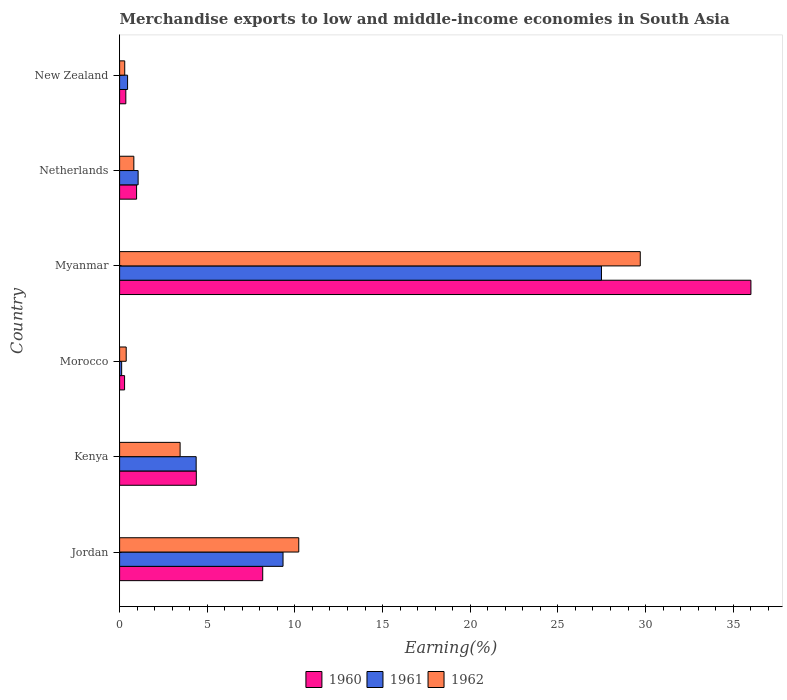How many different coloured bars are there?
Offer a very short reply. 3. Are the number of bars per tick equal to the number of legend labels?
Your answer should be compact. Yes. Are the number of bars on each tick of the Y-axis equal?
Give a very brief answer. Yes. What is the label of the 2nd group of bars from the top?
Offer a very short reply. Netherlands. In how many cases, is the number of bars for a given country not equal to the number of legend labels?
Ensure brevity in your answer.  0. What is the percentage of amount earned from merchandise exports in 1961 in Morocco?
Keep it short and to the point. 0.12. Across all countries, what is the maximum percentage of amount earned from merchandise exports in 1961?
Your answer should be very brief. 27.48. Across all countries, what is the minimum percentage of amount earned from merchandise exports in 1961?
Offer a very short reply. 0.12. In which country was the percentage of amount earned from merchandise exports in 1961 maximum?
Provide a short and direct response. Myanmar. In which country was the percentage of amount earned from merchandise exports in 1961 minimum?
Keep it short and to the point. Morocco. What is the total percentage of amount earned from merchandise exports in 1961 in the graph?
Ensure brevity in your answer.  42.8. What is the difference between the percentage of amount earned from merchandise exports in 1960 in Netherlands and that in New Zealand?
Make the answer very short. 0.61. What is the difference between the percentage of amount earned from merchandise exports in 1962 in Jordan and the percentage of amount earned from merchandise exports in 1961 in Kenya?
Your response must be concise. 5.85. What is the average percentage of amount earned from merchandise exports in 1961 per country?
Your answer should be very brief. 7.13. What is the difference between the percentage of amount earned from merchandise exports in 1962 and percentage of amount earned from merchandise exports in 1960 in Kenya?
Your response must be concise. -0.92. In how many countries, is the percentage of amount earned from merchandise exports in 1961 greater than 21 %?
Make the answer very short. 1. What is the ratio of the percentage of amount earned from merchandise exports in 1962 in Kenya to that in Myanmar?
Your response must be concise. 0.12. Is the difference between the percentage of amount earned from merchandise exports in 1962 in Morocco and Myanmar greater than the difference between the percentage of amount earned from merchandise exports in 1960 in Morocco and Myanmar?
Provide a short and direct response. Yes. What is the difference between the highest and the second highest percentage of amount earned from merchandise exports in 1962?
Your answer should be very brief. 19.48. What is the difference between the highest and the lowest percentage of amount earned from merchandise exports in 1962?
Offer a terse response. 29.4. What does the 2nd bar from the top in Kenya represents?
Your answer should be compact. 1961. Are all the bars in the graph horizontal?
Your answer should be very brief. Yes. How many countries are there in the graph?
Provide a short and direct response. 6. What is the difference between two consecutive major ticks on the X-axis?
Offer a very short reply. 5. Are the values on the major ticks of X-axis written in scientific E-notation?
Provide a succinct answer. No. Where does the legend appear in the graph?
Make the answer very short. Bottom center. What is the title of the graph?
Give a very brief answer. Merchandise exports to low and middle-income economies in South Asia. Does "1972" appear as one of the legend labels in the graph?
Offer a very short reply. No. What is the label or title of the X-axis?
Keep it short and to the point. Earning(%). What is the Earning(%) of 1960 in Jordan?
Provide a succinct answer. 8.16. What is the Earning(%) of 1961 in Jordan?
Your answer should be very brief. 9.32. What is the Earning(%) in 1962 in Jordan?
Your answer should be compact. 10.22. What is the Earning(%) of 1960 in Kenya?
Offer a very short reply. 4.38. What is the Earning(%) of 1961 in Kenya?
Your response must be concise. 4.37. What is the Earning(%) of 1962 in Kenya?
Provide a short and direct response. 3.45. What is the Earning(%) in 1960 in Morocco?
Provide a short and direct response. 0.28. What is the Earning(%) in 1961 in Morocco?
Provide a succinct answer. 0.12. What is the Earning(%) of 1962 in Morocco?
Provide a short and direct response. 0.38. What is the Earning(%) of 1960 in Myanmar?
Your answer should be compact. 36.01. What is the Earning(%) in 1961 in Myanmar?
Keep it short and to the point. 27.48. What is the Earning(%) in 1962 in Myanmar?
Offer a terse response. 29.7. What is the Earning(%) in 1960 in Netherlands?
Ensure brevity in your answer.  0.97. What is the Earning(%) of 1961 in Netherlands?
Offer a terse response. 1.06. What is the Earning(%) in 1962 in Netherlands?
Provide a succinct answer. 0.81. What is the Earning(%) in 1960 in New Zealand?
Keep it short and to the point. 0.36. What is the Earning(%) of 1961 in New Zealand?
Offer a very short reply. 0.45. What is the Earning(%) of 1962 in New Zealand?
Your response must be concise. 0.29. Across all countries, what is the maximum Earning(%) in 1960?
Keep it short and to the point. 36.01. Across all countries, what is the maximum Earning(%) of 1961?
Keep it short and to the point. 27.48. Across all countries, what is the maximum Earning(%) in 1962?
Provide a short and direct response. 29.7. Across all countries, what is the minimum Earning(%) in 1960?
Offer a very short reply. 0.28. Across all countries, what is the minimum Earning(%) of 1961?
Your response must be concise. 0.12. Across all countries, what is the minimum Earning(%) of 1962?
Provide a succinct answer. 0.29. What is the total Earning(%) of 1960 in the graph?
Your answer should be very brief. 50.16. What is the total Earning(%) in 1961 in the graph?
Ensure brevity in your answer.  42.8. What is the total Earning(%) of 1962 in the graph?
Offer a terse response. 44.85. What is the difference between the Earning(%) in 1960 in Jordan and that in Kenya?
Your response must be concise. 3.79. What is the difference between the Earning(%) in 1961 in Jordan and that in Kenya?
Your answer should be very brief. 4.96. What is the difference between the Earning(%) in 1962 in Jordan and that in Kenya?
Your answer should be compact. 6.77. What is the difference between the Earning(%) of 1960 in Jordan and that in Morocco?
Ensure brevity in your answer.  7.88. What is the difference between the Earning(%) of 1961 in Jordan and that in Morocco?
Provide a succinct answer. 9.21. What is the difference between the Earning(%) in 1962 in Jordan and that in Morocco?
Your response must be concise. 9.84. What is the difference between the Earning(%) of 1960 in Jordan and that in Myanmar?
Make the answer very short. -27.85. What is the difference between the Earning(%) in 1961 in Jordan and that in Myanmar?
Your answer should be compact. -18.16. What is the difference between the Earning(%) of 1962 in Jordan and that in Myanmar?
Ensure brevity in your answer.  -19.48. What is the difference between the Earning(%) in 1960 in Jordan and that in Netherlands?
Offer a terse response. 7.19. What is the difference between the Earning(%) in 1961 in Jordan and that in Netherlands?
Offer a very short reply. 8.27. What is the difference between the Earning(%) in 1962 in Jordan and that in Netherlands?
Ensure brevity in your answer.  9.41. What is the difference between the Earning(%) of 1960 in Jordan and that in New Zealand?
Offer a terse response. 7.81. What is the difference between the Earning(%) in 1961 in Jordan and that in New Zealand?
Give a very brief answer. 8.87. What is the difference between the Earning(%) of 1962 in Jordan and that in New Zealand?
Ensure brevity in your answer.  9.93. What is the difference between the Earning(%) in 1960 in Kenya and that in Morocco?
Keep it short and to the point. 4.09. What is the difference between the Earning(%) in 1961 in Kenya and that in Morocco?
Provide a short and direct response. 4.25. What is the difference between the Earning(%) in 1962 in Kenya and that in Morocco?
Ensure brevity in your answer.  3.07. What is the difference between the Earning(%) in 1960 in Kenya and that in Myanmar?
Offer a terse response. -31.63. What is the difference between the Earning(%) of 1961 in Kenya and that in Myanmar?
Keep it short and to the point. -23.12. What is the difference between the Earning(%) in 1962 in Kenya and that in Myanmar?
Ensure brevity in your answer.  -26.25. What is the difference between the Earning(%) of 1960 in Kenya and that in Netherlands?
Provide a short and direct response. 3.41. What is the difference between the Earning(%) of 1961 in Kenya and that in Netherlands?
Provide a succinct answer. 3.31. What is the difference between the Earning(%) of 1962 in Kenya and that in Netherlands?
Provide a short and direct response. 2.64. What is the difference between the Earning(%) of 1960 in Kenya and that in New Zealand?
Provide a short and direct response. 4.02. What is the difference between the Earning(%) of 1961 in Kenya and that in New Zealand?
Provide a succinct answer. 3.91. What is the difference between the Earning(%) of 1962 in Kenya and that in New Zealand?
Ensure brevity in your answer.  3.16. What is the difference between the Earning(%) of 1960 in Morocco and that in Myanmar?
Your response must be concise. -35.73. What is the difference between the Earning(%) of 1961 in Morocco and that in Myanmar?
Make the answer very short. -27.37. What is the difference between the Earning(%) in 1962 in Morocco and that in Myanmar?
Ensure brevity in your answer.  -29.32. What is the difference between the Earning(%) in 1960 in Morocco and that in Netherlands?
Give a very brief answer. -0.68. What is the difference between the Earning(%) of 1961 in Morocco and that in Netherlands?
Offer a very short reply. -0.94. What is the difference between the Earning(%) of 1962 in Morocco and that in Netherlands?
Offer a terse response. -0.44. What is the difference between the Earning(%) in 1960 in Morocco and that in New Zealand?
Make the answer very short. -0.07. What is the difference between the Earning(%) of 1961 in Morocco and that in New Zealand?
Provide a succinct answer. -0.34. What is the difference between the Earning(%) in 1962 in Morocco and that in New Zealand?
Provide a short and direct response. 0.08. What is the difference between the Earning(%) of 1960 in Myanmar and that in Netherlands?
Provide a short and direct response. 35.04. What is the difference between the Earning(%) in 1961 in Myanmar and that in Netherlands?
Offer a very short reply. 26.43. What is the difference between the Earning(%) of 1962 in Myanmar and that in Netherlands?
Your answer should be compact. 28.89. What is the difference between the Earning(%) of 1960 in Myanmar and that in New Zealand?
Provide a short and direct response. 35.65. What is the difference between the Earning(%) in 1961 in Myanmar and that in New Zealand?
Your response must be concise. 27.03. What is the difference between the Earning(%) in 1962 in Myanmar and that in New Zealand?
Your answer should be compact. 29.4. What is the difference between the Earning(%) in 1960 in Netherlands and that in New Zealand?
Make the answer very short. 0.61. What is the difference between the Earning(%) of 1961 in Netherlands and that in New Zealand?
Offer a terse response. 0.6. What is the difference between the Earning(%) in 1962 in Netherlands and that in New Zealand?
Make the answer very short. 0.52. What is the difference between the Earning(%) in 1960 in Jordan and the Earning(%) in 1961 in Kenya?
Give a very brief answer. 3.8. What is the difference between the Earning(%) in 1960 in Jordan and the Earning(%) in 1962 in Kenya?
Offer a terse response. 4.71. What is the difference between the Earning(%) of 1961 in Jordan and the Earning(%) of 1962 in Kenya?
Your answer should be very brief. 5.87. What is the difference between the Earning(%) in 1960 in Jordan and the Earning(%) in 1961 in Morocco?
Offer a terse response. 8.05. What is the difference between the Earning(%) in 1960 in Jordan and the Earning(%) in 1962 in Morocco?
Your answer should be compact. 7.79. What is the difference between the Earning(%) of 1961 in Jordan and the Earning(%) of 1962 in Morocco?
Offer a very short reply. 8.95. What is the difference between the Earning(%) in 1960 in Jordan and the Earning(%) in 1961 in Myanmar?
Provide a succinct answer. -19.32. What is the difference between the Earning(%) of 1960 in Jordan and the Earning(%) of 1962 in Myanmar?
Provide a succinct answer. -21.53. What is the difference between the Earning(%) in 1961 in Jordan and the Earning(%) in 1962 in Myanmar?
Offer a terse response. -20.38. What is the difference between the Earning(%) of 1960 in Jordan and the Earning(%) of 1961 in Netherlands?
Provide a succinct answer. 7.11. What is the difference between the Earning(%) of 1960 in Jordan and the Earning(%) of 1962 in Netherlands?
Give a very brief answer. 7.35. What is the difference between the Earning(%) of 1961 in Jordan and the Earning(%) of 1962 in Netherlands?
Ensure brevity in your answer.  8.51. What is the difference between the Earning(%) in 1960 in Jordan and the Earning(%) in 1961 in New Zealand?
Give a very brief answer. 7.71. What is the difference between the Earning(%) in 1960 in Jordan and the Earning(%) in 1962 in New Zealand?
Make the answer very short. 7.87. What is the difference between the Earning(%) in 1961 in Jordan and the Earning(%) in 1962 in New Zealand?
Give a very brief answer. 9.03. What is the difference between the Earning(%) of 1960 in Kenya and the Earning(%) of 1961 in Morocco?
Offer a terse response. 4.26. What is the difference between the Earning(%) of 1960 in Kenya and the Earning(%) of 1962 in Morocco?
Your answer should be compact. 4. What is the difference between the Earning(%) of 1961 in Kenya and the Earning(%) of 1962 in Morocco?
Give a very brief answer. 3.99. What is the difference between the Earning(%) of 1960 in Kenya and the Earning(%) of 1961 in Myanmar?
Offer a terse response. -23.11. What is the difference between the Earning(%) in 1960 in Kenya and the Earning(%) in 1962 in Myanmar?
Your answer should be very brief. -25.32. What is the difference between the Earning(%) of 1961 in Kenya and the Earning(%) of 1962 in Myanmar?
Provide a succinct answer. -25.33. What is the difference between the Earning(%) in 1960 in Kenya and the Earning(%) in 1961 in Netherlands?
Provide a short and direct response. 3.32. What is the difference between the Earning(%) of 1960 in Kenya and the Earning(%) of 1962 in Netherlands?
Provide a short and direct response. 3.56. What is the difference between the Earning(%) of 1961 in Kenya and the Earning(%) of 1962 in Netherlands?
Make the answer very short. 3.55. What is the difference between the Earning(%) of 1960 in Kenya and the Earning(%) of 1961 in New Zealand?
Give a very brief answer. 3.92. What is the difference between the Earning(%) in 1960 in Kenya and the Earning(%) in 1962 in New Zealand?
Offer a terse response. 4.08. What is the difference between the Earning(%) in 1961 in Kenya and the Earning(%) in 1962 in New Zealand?
Ensure brevity in your answer.  4.07. What is the difference between the Earning(%) in 1960 in Morocco and the Earning(%) in 1961 in Myanmar?
Your answer should be compact. -27.2. What is the difference between the Earning(%) in 1960 in Morocco and the Earning(%) in 1962 in Myanmar?
Make the answer very short. -29.41. What is the difference between the Earning(%) of 1961 in Morocco and the Earning(%) of 1962 in Myanmar?
Your answer should be compact. -29.58. What is the difference between the Earning(%) in 1960 in Morocco and the Earning(%) in 1961 in Netherlands?
Your answer should be compact. -0.77. What is the difference between the Earning(%) of 1960 in Morocco and the Earning(%) of 1962 in Netherlands?
Offer a very short reply. -0.53. What is the difference between the Earning(%) of 1961 in Morocco and the Earning(%) of 1962 in Netherlands?
Give a very brief answer. -0.7. What is the difference between the Earning(%) of 1960 in Morocco and the Earning(%) of 1961 in New Zealand?
Offer a terse response. -0.17. What is the difference between the Earning(%) in 1960 in Morocco and the Earning(%) in 1962 in New Zealand?
Offer a terse response. -0.01. What is the difference between the Earning(%) in 1961 in Morocco and the Earning(%) in 1962 in New Zealand?
Your answer should be compact. -0.18. What is the difference between the Earning(%) in 1960 in Myanmar and the Earning(%) in 1961 in Netherlands?
Your response must be concise. 34.95. What is the difference between the Earning(%) in 1960 in Myanmar and the Earning(%) in 1962 in Netherlands?
Your answer should be very brief. 35.2. What is the difference between the Earning(%) in 1961 in Myanmar and the Earning(%) in 1962 in Netherlands?
Give a very brief answer. 26.67. What is the difference between the Earning(%) in 1960 in Myanmar and the Earning(%) in 1961 in New Zealand?
Offer a terse response. 35.55. What is the difference between the Earning(%) in 1960 in Myanmar and the Earning(%) in 1962 in New Zealand?
Make the answer very short. 35.72. What is the difference between the Earning(%) of 1961 in Myanmar and the Earning(%) of 1962 in New Zealand?
Provide a succinct answer. 27.19. What is the difference between the Earning(%) of 1960 in Netherlands and the Earning(%) of 1961 in New Zealand?
Offer a very short reply. 0.51. What is the difference between the Earning(%) of 1960 in Netherlands and the Earning(%) of 1962 in New Zealand?
Ensure brevity in your answer.  0.68. What is the difference between the Earning(%) of 1961 in Netherlands and the Earning(%) of 1962 in New Zealand?
Your answer should be very brief. 0.76. What is the average Earning(%) in 1960 per country?
Offer a terse response. 8.36. What is the average Earning(%) of 1961 per country?
Your response must be concise. 7.13. What is the average Earning(%) of 1962 per country?
Keep it short and to the point. 7.47. What is the difference between the Earning(%) in 1960 and Earning(%) in 1961 in Jordan?
Your response must be concise. -1.16. What is the difference between the Earning(%) in 1960 and Earning(%) in 1962 in Jordan?
Keep it short and to the point. -2.06. What is the difference between the Earning(%) of 1961 and Earning(%) of 1962 in Jordan?
Keep it short and to the point. -0.9. What is the difference between the Earning(%) in 1960 and Earning(%) in 1961 in Kenya?
Your answer should be compact. 0.01. What is the difference between the Earning(%) of 1960 and Earning(%) of 1962 in Kenya?
Offer a terse response. 0.92. What is the difference between the Earning(%) in 1961 and Earning(%) in 1962 in Kenya?
Provide a short and direct response. 0.92. What is the difference between the Earning(%) in 1960 and Earning(%) in 1961 in Morocco?
Offer a very short reply. 0.17. What is the difference between the Earning(%) in 1960 and Earning(%) in 1962 in Morocco?
Your answer should be compact. -0.09. What is the difference between the Earning(%) of 1961 and Earning(%) of 1962 in Morocco?
Your answer should be very brief. -0.26. What is the difference between the Earning(%) of 1960 and Earning(%) of 1961 in Myanmar?
Ensure brevity in your answer.  8.52. What is the difference between the Earning(%) in 1960 and Earning(%) in 1962 in Myanmar?
Offer a very short reply. 6.31. What is the difference between the Earning(%) in 1961 and Earning(%) in 1962 in Myanmar?
Offer a very short reply. -2.21. What is the difference between the Earning(%) in 1960 and Earning(%) in 1961 in Netherlands?
Provide a succinct answer. -0.09. What is the difference between the Earning(%) in 1960 and Earning(%) in 1962 in Netherlands?
Offer a very short reply. 0.16. What is the difference between the Earning(%) of 1961 and Earning(%) of 1962 in Netherlands?
Your response must be concise. 0.24. What is the difference between the Earning(%) of 1960 and Earning(%) of 1961 in New Zealand?
Give a very brief answer. -0.1. What is the difference between the Earning(%) of 1960 and Earning(%) of 1962 in New Zealand?
Give a very brief answer. 0.06. What is the difference between the Earning(%) in 1961 and Earning(%) in 1962 in New Zealand?
Provide a short and direct response. 0.16. What is the ratio of the Earning(%) in 1960 in Jordan to that in Kenya?
Offer a terse response. 1.87. What is the ratio of the Earning(%) in 1961 in Jordan to that in Kenya?
Ensure brevity in your answer.  2.13. What is the ratio of the Earning(%) of 1962 in Jordan to that in Kenya?
Your response must be concise. 2.96. What is the ratio of the Earning(%) of 1960 in Jordan to that in Morocco?
Offer a terse response. 28.77. What is the ratio of the Earning(%) of 1961 in Jordan to that in Morocco?
Keep it short and to the point. 79.68. What is the ratio of the Earning(%) in 1962 in Jordan to that in Morocco?
Provide a short and direct response. 27.14. What is the ratio of the Earning(%) in 1960 in Jordan to that in Myanmar?
Offer a very short reply. 0.23. What is the ratio of the Earning(%) of 1961 in Jordan to that in Myanmar?
Your response must be concise. 0.34. What is the ratio of the Earning(%) of 1962 in Jordan to that in Myanmar?
Make the answer very short. 0.34. What is the ratio of the Earning(%) in 1960 in Jordan to that in Netherlands?
Your response must be concise. 8.43. What is the ratio of the Earning(%) in 1961 in Jordan to that in Netherlands?
Offer a very short reply. 8.82. What is the ratio of the Earning(%) in 1962 in Jordan to that in Netherlands?
Provide a succinct answer. 12.58. What is the ratio of the Earning(%) in 1960 in Jordan to that in New Zealand?
Ensure brevity in your answer.  22.99. What is the ratio of the Earning(%) in 1961 in Jordan to that in New Zealand?
Your answer should be very brief. 20.5. What is the ratio of the Earning(%) in 1962 in Jordan to that in New Zealand?
Your response must be concise. 34.92. What is the ratio of the Earning(%) of 1960 in Kenya to that in Morocco?
Your response must be concise. 15.42. What is the ratio of the Earning(%) in 1961 in Kenya to that in Morocco?
Offer a very short reply. 37.33. What is the ratio of the Earning(%) in 1962 in Kenya to that in Morocco?
Provide a short and direct response. 9.17. What is the ratio of the Earning(%) of 1960 in Kenya to that in Myanmar?
Ensure brevity in your answer.  0.12. What is the ratio of the Earning(%) in 1961 in Kenya to that in Myanmar?
Offer a very short reply. 0.16. What is the ratio of the Earning(%) of 1962 in Kenya to that in Myanmar?
Your answer should be compact. 0.12. What is the ratio of the Earning(%) of 1960 in Kenya to that in Netherlands?
Provide a succinct answer. 4.52. What is the ratio of the Earning(%) in 1961 in Kenya to that in Netherlands?
Keep it short and to the point. 4.13. What is the ratio of the Earning(%) of 1962 in Kenya to that in Netherlands?
Keep it short and to the point. 4.25. What is the ratio of the Earning(%) of 1960 in Kenya to that in New Zealand?
Your answer should be compact. 12.32. What is the ratio of the Earning(%) in 1961 in Kenya to that in New Zealand?
Offer a terse response. 9.6. What is the ratio of the Earning(%) in 1962 in Kenya to that in New Zealand?
Make the answer very short. 11.79. What is the ratio of the Earning(%) in 1960 in Morocco to that in Myanmar?
Provide a succinct answer. 0.01. What is the ratio of the Earning(%) of 1961 in Morocco to that in Myanmar?
Provide a succinct answer. 0. What is the ratio of the Earning(%) of 1962 in Morocco to that in Myanmar?
Offer a very short reply. 0.01. What is the ratio of the Earning(%) in 1960 in Morocco to that in Netherlands?
Provide a succinct answer. 0.29. What is the ratio of the Earning(%) in 1961 in Morocco to that in Netherlands?
Your answer should be compact. 0.11. What is the ratio of the Earning(%) in 1962 in Morocco to that in Netherlands?
Make the answer very short. 0.46. What is the ratio of the Earning(%) of 1960 in Morocco to that in New Zealand?
Keep it short and to the point. 0.8. What is the ratio of the Earning(%) of 1961 in Morocco to that in New Zealand?
Provide a short and direct response. 0.26. What is the ratio of the Earning(%) in 1962 in Morocco to that in New Zealand?
Make the answer very short. 1.29. What is the ratio of the Earning(%) of 1960 in Myanmar to that in Netherlands?
Provide a short and direct response. 37.19. What is the ratio of the Earning(%) in 1961 in Myanmar to that in Netherlands?
Provide a succinct answer. 26.02. What is the ratio of the Earning(%) in 1962 in Myanmar to that in Netherlands?
Make the answer very short. 36.57. What is the ratio of the Earning(%) in 1960 in Myanmar to that in New Zealand?
Ensure brevity in your answer.  101.41. What is the ratio of the Earning(%) of 1961 in Myanmar to that in New Zealand?
Your answer should be very brief. 60.43. What is the ratio of the Earning(%) of 1962 in Myanmar to that in New Zealand?
Your response must be concise. 101.47. What is the ratio of the Earning(%) of 1960 in Netherlands to that in New Zealand?
Offer a very short reply. 2.73. What is the ratio of the Earning(%) in 1961 in Netherlands to that in New Zealand?
Keep it short and to the point. 2.32. What is the ratio of the Earning(%) in 1962 in Netherlands to that in New Zealand?
Give a very brief answer. 2.78. What is the difference between the highest and the second highest Earning(%) in 1960?
Your answer should be compact. 27.85. What is the difference between the highest and the second highest Earning(%) of 1961?
Your response must be concise. 18.16. What is the difference between the highest and the second highest Earning(%) of 1962?
Your answer should be compact. 19.48. What is the difference between the highest and the lowest Earning(%) of 1960?
Keep it short and to the point. 35.73. What is the difference between the highest and the lowest Earning(%) of 1961?
Offer a very short reply. 27.37. What is the difference between the highest and the lowest Earning(%) in 1962?
Keep it short and to the point. 29.4. 